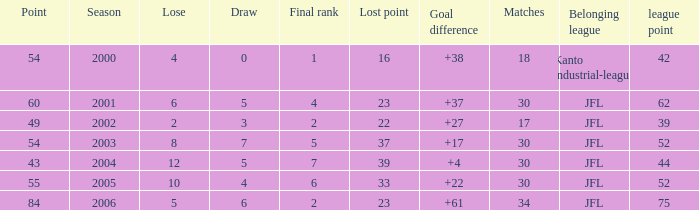Tell me the highest matches for point 43 and final rank less than 7 None. 